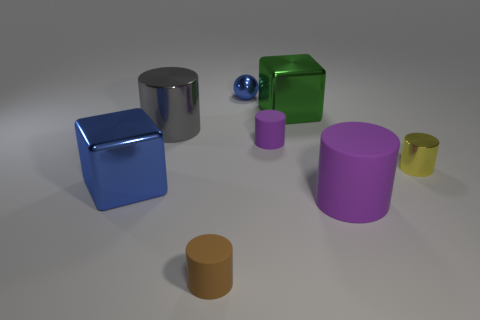What size is the gray shiny thing that is the same shape as the small purple thing?
Your response must be concise. Large. What number of small cylinders are to the right of the tiny sphere and on the left side of the yellow object?
Offer a very short reply. 1. There is a green metal object; does it have the same shape as the matte object that is behind the large purple cylinder?
Keep it short and to the point. No. Is the number of small purple things right of the large purple object greater than the number of blue blocks?
Your answer should be compact. No. Is the number of spheres on the right side of the tiny blue shiny sphere less than the number of big gray things?
Offer a terse response. Yes. How many shiny blocks are the same color as the small metal ball?
Provide a succinct answer. 1. There is a thing that is on the left side of the small blue metallic thing and right of the gray shiny object; what material is it?
Keep it short and to the point. Rubber. Does the metal cube that is on the right side of the brown thing have the same color as the block to the left of the large green cube?
Keep it short and to the point. No. How many purple objects are either cylinders or small things?
Make the answer very short. 2. Are there fewer tiny blue things on the left side of the blue sphere than gray shiny objects to the right of the gray object?
Keep it short and to the point. No. 